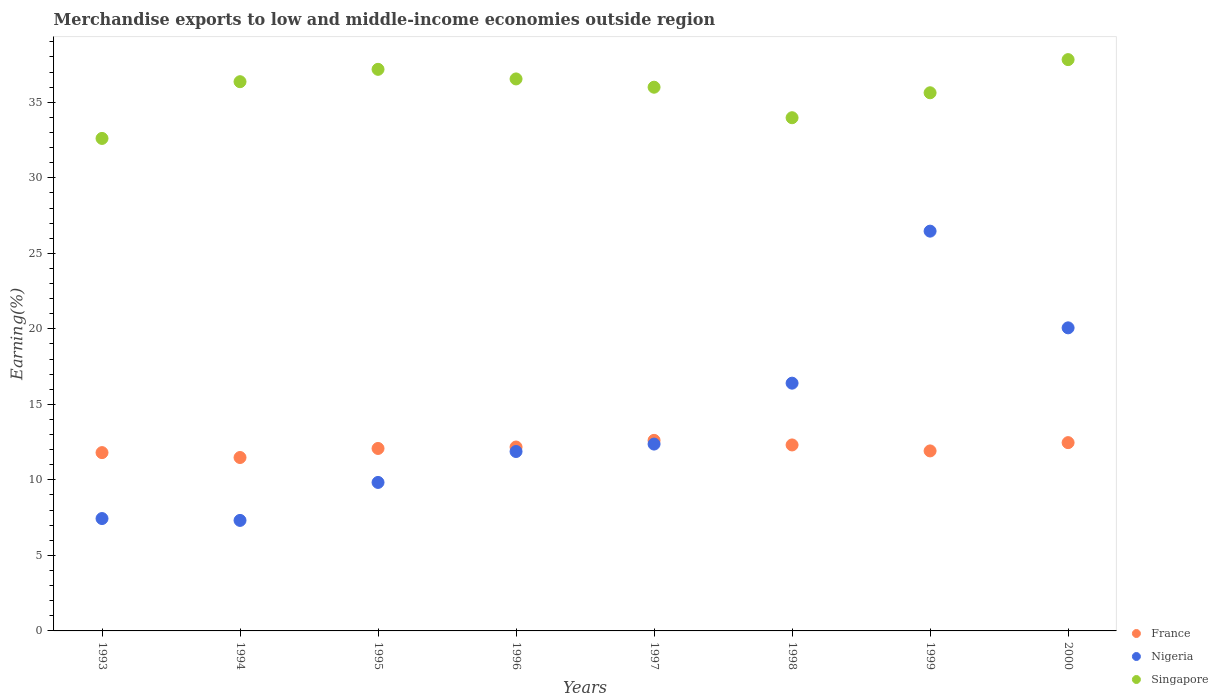How many different coloured dotlines are there?
Make the answer very short. 3. What is the percentage of amount earned from merchandise exports in France in 1999?
Your response must be concise. 11.92. Across all years, what is the maximum percentage of amount earned from merchandise exports in Nigeria?
Ensure brevity in your answer.  26.47. Across all years, what is the minimum percentage of amount earned from merchandise exports in Nigeria?
Your answer should be compact. 7.32. In which year was the percentage of amount earned from merchandise exports in France maximum?
Your response must be concise. 1997. What is the total percentage of amount earned from merchandise exports in Singapore in the graph?
Make the answer very short. 286.12. What is the difference between the percentage of amount earned from merchandise exports in Nigeria in 1994 and that in 1996?
Offer a terse response. -4.56. What is the difference between the percentage of amount earned from merchandise exports in Nigeria in 1995 and the percentage of amount earned from merchandise exports in France in 1996?
Offer a terse response. -2.34. What is the average percentage of amount earned from merchandise exports in Nigeria per year?
Offer a terse response. 13.97. In the year 1995, what is the difference between the percentage of amount earned from merchandise exports in Singapore and percentage of amount earned from merchandise exports in France?
Your response must be concise. 25.1. What is the ratio of the percentage of amount earned from merchandise exports in Singapore in 1993 to that in 1997?
Give a very brief answer. 0.91. What is the difference between the highest and the second highest percentage of amount earned from merchandise exports in France?
Your answer should be very brief. 0.15. What is the difference between the highest and the lowest percentage of amount earned from merchandise exports in France?
Your response must be concise. 1.13. In how many years, is the percentage of amount earned from merchandise exports in Singapore greater than the average percentage of amount earned from merchandise exports in Singapore taken over all years?
Your answer should be very brief. 5. Is the sum of the percentage of amount earned from merchandise exports in Nigeria in 1995 and 1996 greater than the maximum percentage of amount earned from merchandise exports in Singapore across all years?
Make the answer very short. No. Is the percentage of amount earned from merchandise exports in Singapore strictly greater than the percentage of amount earned from merchandise exports in Nigeria over the years?
Give a very brief answer. Yes. How many dotlines are there?
Ensure brevity in your answer.  3. Does the graph contain any zero values?
Your answer should be compact. No. Does the graph contain grids?
Provide a succinct answer. No. How many legend labels are there?
Make the answer very short. 3. How are the legend labels stacked?
Offer a very short reply. Vertical. What is the title of the graph?
Your answer should be compact. Merchandise exports to low and middle-income economies outside region. What is the label or title of the X-axis?
Give a very brief answer. Years. What is the label or title of the Y-axis?
Keep it short and to the point. Earning(%). What is the Earning(%) of France in 1993?
Offer a terse response. 11.8. What is the Earning(%) of Nigeria in 1993?
Offer a very short reply. 7.44. What is the Earning(%) of Singapore in 1993?
Provide a succinct answer. 32.61. What is the Earning(%) in France in 1994?
Offer a very short reply. 11.48. What is the Earning(%) in Nigeria in 1994?
Offer a very short reply. 7.32. What is the Earning(%) of Singapore in 1994?
Keep it short and to the point. 36.36. What is the Earning(%) of France in 1995?
Offer a very short reply. 12.08. What is the Earning(%) in Nigeria in 1995?
Your answer should be very brief. 9.83. What is the Earning(%) of Singapore in 1995?
Provide a short and direct response. 37.18. What is the Earning(%) of France in 1996?
Provide a succinct answer. 12.17. What is the Earning(%) of Nigeria in 1996?
Provide a succinct answer. 11.88. What is the Earning(%) of Singapore in 1996?
Provide a succinct answer. 36.55. What is the Earning(%) of France in 1997?
Ensure brevity in your answer.  12.62. What is the Earning(%) of Nigeria in 1997?
Offer a terse response. 12.37. What is the Earning(%) of Singapore in 1997?
Give a very brief answer. 36. What is the Earning(%) of France in 1998?
Offer a very short reply. 12.31. What is the Earning(%) in Nigeria in 1998?
Offer a very short reply. 16.4. What is the Earning(%) in Singapore in 1998?
Give a very brief answer. 33.98. What is the Earning(%) in France in 1999?
Give a very brief answer. 11.92. What is the Earning(%) in Nigeria in 1999?
Offer a very short reply. 26.47. What is the Earning(%) of Singapore in 1999?
Offer a very short reply. 35.63. What is the Earning(%) in France in 2000?
Ensure brevity in your answer.  12.47. What is the Earning(%) of Nigeria in 2000?
Provide a succinct answer. 20.07. What is the Earning(%) of Singapore in 2000?
Keep it short and to the point. 37.82. Across all years, what is the maximum Earning(%) of France?
Give a very brief answer. 12.62. Across all years, what is the maximum Earning(%) in Nigeria?
Offer a very short reply. 26.47. Across all years, what is the maximum Earning(%) in Singapore?
Provide a short and direct response. 37.82. Across all years, what is the minimum Earning(%) of France?
Ensure brevity in your answer.  11.48. Across all years, what is the minimum Earning(%) of Nigeria?
Your answer should be compact. 7.32. Across all years, what is the minimum Earning(%) of Singapore?
Provide a short and direct response. 32.61. What is the total Earning(%) in France in the graph?
Provide a succinct answer. 96.85. What is the total Earning(%) in Nigeria in the graph?
Your response must be concise. 111.77. What is the total Earning(%) of Singapore in the graph?
Provide a short and direct response. 286.12. What is the difference between the Earning(%) of France in 1993 and that in 1994?
Your answer should be compact. 0.32. What is the difference between the Earning(%) of Nigeria in 1993 and that in 1994?
Your response must be concise. 0.12. What is the difference between the Earning(%) in Singapore in 1993 and that in 1994?
Offer a terse response. -3.76. What is the difference between the Earning(%) of France in 1993 and that in 1995?
Ensure brevity in your answer.  -0.28. What is the difference between the Earning(%) of Nigeria in 1993 and that in 1995?
Offer a terse response. -2.39. What is the difference between the Earning(%) in Singapore in 1993 and that in 1995?
Your response must be concise. -4.57. What is the difference between the Earning(%) of France in 1993 and that in 1996?
Your answer should be compact. -0.37. What is the difference between the Earning(%) of Nigeria in 1993 and that in 1996?
Make the answer very short. -4.44. What is the difference between the Earning(%) of Singapore in 1993 and that in 1996?
Ensure brevity in your answer.  -3.94. What is the difference between the Earning(%) in France in 1993 and that in 1997?
Your answer should be compact. -0.81. What is the difference between the Earning(%) of Nigeria in 1993 and that in 1997?
Give a very brief answer. -4.93. What is the difference between the Earning(%) in Singapore in 1993 and that in 1997?
Provide a succinct answer. -3.39. What is the difference between the Earning(%) in France in 1993 and that in 1998?
Provide a succinct answer. -0.51. What is the difference between the Earning(%) of Nigeria in 1993 and that in 1998?
Your answer should be very brief. -8.96. What is the difference between the Earning(%) in Singapore in 1993 and that in 1998?
Give a very brief answer. -1.37. What is the difference between the Earning(%) in France in 1993 and that in 1999?
Provide a short and direct response. -0.11. What is the difference between the Earning(%) in Nigeria in 1993 and that in 1999?
Provide a short and direct response. -19.03. What is the difference between the Earning(%) in Singapore in 1993 and that in 1999?
Offer a terse response. -3.02. What is the difference between the Earning(%) in France in 1993 and that in 2000?
Your answer should be compact. -0.66. What is the difference between the Earning(%) of Nigeria in 1993 and that in 2000?
Give a very brief answer. -12.63. What is the difference between the Earning(%) in Singapore in 1993 and that in 2000?
Keep it short and to the point. -5.22. What is the difference between the Earning(%) of France in 1994 and that in 1995?
Provide a succinct answer. -0.6. What is the difference between the Earning(%) in Nigeria in 1994 and that in 1995?
Your answer should be compact. -2.51. What is the difference between the Earning(%) in Singapore in 1994 and that in 1995?
Ensure brevity in your answer.  -0.82. What is the difference between the Earning(%) of France in 1994 and that in 1996?
Your answer should be compact. -0.69. What is the difference between the Earning(%) in Nigeria in 1994 and that in 1996?
Give a very brief answer. -4.56. What is the difference between the Earning(%) of Singapore in 1994 and that in 1996?
Give a very brief answer. -0.18. What is the difference between the Earning(%) in France in 1994 and that in 1997?
Your response must be concise. -1.13. What is the difference between the Earning(%) of Nigeria in 1994 and that in 1997?
Give a very brief answer. -5.05. What is the difference between the Earning(%) in Singapore in 1994 and that in 1997?
Your response must be concise. 0.37. What is the difference between the Earning(%) in France in 1994 and that in 1998?
Provide a short and direct response. -0.83. What is the difference between the Earning(%) in Nigeria in 1994 and that in 1998?
Offer a terse response. -9.09. What is the difference between the Earning(%) of Singapore in 1994 and that in 1998?
Keep it short and to the point. 2.38. What is the difference between the Earning(%) of France in 1994 and that in 1999?
Your answer should be compact. -0.44. What is the difference between the Earning(%) of Nigeria in 1994 and that in 1999?
Your answer should be very brief. -19.15. What is the difference between the Earning(%) of Singapore in 1994 and that in 1999?
Make the answer very short. 0.73. What is the difference between the Earning(%) in France in 1994 and that in 2000?
Your answer should be very brief. -0.98. What is the difference between the Earning(%) of Nigeria in 1994 and that in 2000?
Your answer should be very brief. -12.75. What is the difference between the Earning(%) in Singapore in 1994 and that in 2000?
Make the answer very short. -1.46. What is the difference between the Earning(%) of France in 1995 and that in 1996?
Keep it short and to the point. -0.09. What is the difference between the Earning(%) of Nigeria in 1995 and that in 1996?
Offer a terse response. -2.05. What is the difference between the Earning(%) in Singapore in 1995 and that in 1996?
Make the answer very short. 0.64. What is the difference between the Earning(%) of France in 1995 and that in 1997?
Give a very brief answer. -0.54. What is the difference between the Earning(%) of Nigeria in 1995 and that in 1997?
Keep it short and to the point. -2.54. What is the difference between the Earning(%) of Singapore in 1995 and that in 1997?
Offer a very short reply. 1.18. What is the difference between the Earning(%) in France in 1995 and that in 1998?
Keep it short and to the point. -0.23. What is the difference between the Earning(%) of Nigeria in 1995 and that in 1998?
Your answer should be very brief. -6.57. What is the difference between the Earning(%) in Singapore in 1995 and that in 1998?
Offer a very short reply. 3.2. What is the difference between the Earning(%) in France in 1995 and that in 1999?
Make the answer very short. 0.16. What is the difference between the Earning(%) of Nigeria in 1995 and that in 1999?
Keep it short and to the point. -16.64. What is the difference between the Earning(%) of Singapore in 1995 and that in 1999?
Provide a succinct answer. 1.55. What is the difference between the Earning(%) in France in 1995 and that in 2000?
Your answer should be compact. -0.39. What is the difference between the Earning(%) in Nigeria in 1995 and that in 2000?
Offer a very short reply. -10.23. What is the difference between the Earning(%) of Singapore in 1995 and that in 2000?
Your answer should be compact. -0.64. What is the difference between the Earning(%) of France in 1996 and that in 1997?
Your response must be concise. -0.44. What is the difference between the Earning(%) of Nigeria in 1996 and that in 1997?
Give a very brief answer. -0.49. What is the difference between the Earning(%) of Singapore in 1996 and that in 1997?
Offer a terse response. 0.55. What is the difference between the Earning(%) in France in 1996 and that in 1998?
Provide a short and direct response. -0.14. What is the difference between the Earning(%) of Nigeria in 1996 and that in 1998?
Your answer should be very brief. -4.52. What is the difference between the Earning(%) in Singapore in 1996 and that in 1998?
Your answer should be compact. 2.57. What is the difference between the Earning(%) of France in 1996 and that in 1999?
Offer a terse response. 0.26. What is the difference between the Earning(%) of Nigeria in 1996 and that in 1999?
Provide a short and direct response. -14.59. What is the difference between the Earning(%) in France in 1996 and that in 2000?
Offer a terse response. -0.29. What is the difference between the Earning(%) of Nigeria in 1996 and that in 2000?
Give a very brief answer. -8.19. What is the difference between the Earning(%) of Singapore in 1996 and that in 2000?
Offer a terse response. -1.28. What is the difference between the Earning(%) of France in 1997 and that in 1998?
Your answer should be very brief. 0.3. What is the difference between the Earning(%) of Nigeria in 1997 and that in 1998?
Offer a terse response. -4.03. What is the difference between the Earning(%) of Singapore in 1997 and that in 1998?
Give a very brief answer. 2.02. What is the difference between the Earning(%) of France in 1997 and that in 1999?
Your answer should be very brief. 0.7. What is the difference between the Earning(%) in Nigeria in 1997 and that in 1999?
Your response must be concise. -14.1. What is the difference between the Earning(%) in Singapore in 1997 and that in 1999?
Your answer should be very brief. 0.37. What is the difference between the Earning(%) in France in 1997 and that in 2000?
Give a very brief answer. 0.15. What is the difference between the Earning(%) in Nigeria in 1997 and that in 2000?
Give a very brief answer. -7.7. What is the difference between the Earning(%) of Singapore in 1997 and that in 2000?
Offer a terse response. -1.83. What is the difference between the Earning(%) in France in 1998 and that in 1999?
Make the answer very short. 0.4. What is the difference between the Earning(%) of Nigeria in 1998 and that in 1999?
Make the answer very short. -10.06. What is the difference between the Earning(%) in Singapore in 1998 and that in 1999?
Your answer should be very brief. -1.65. What is the difference between the Earning(%) in France in 1998 and that in 2000?
Provide a succinct answer. -0.15. What is the difference between the Earning(%) of Nigeria in 1998 and that in 2000?
Ensure brevity in your answer.  -3.66. What is the difference between the Earning(%) in Singapore in 1998 and that in 2000?
Make the answer very short. -3.85. What is the difference between the Earning(%) of France in 1999 and that in 2000?
Offer a very short reply. -0.55. What is the difference between the Earning(%) of Nigeria in 1999 and that in 2000?
Your answer should be compact. 6.4. What is the difference between the Earning(%) of Singapore in 1999 and that in 2000?
Your response must be concise. -2.2. What is the difference between the Earning(%) of France in 1993 and the Earning(%) of Nigeria in 1994?
Your response must be concise. 4.49. What is the difference between the Earning(%) of France in 1993 and the Earning(%) of Singapore in 1994?
Provide a short and direct response. -24.56. What is the difference between the Earning(%) of Nigeria in 1993 and the Earning(%) of Singapore in 1994?
Ensure brevity in your answer.  -28.92. What is the difference between the Earning(%) in France in 1993 and the Earning(%) in Nigeria in 1995?
Offer a very short reply. 1.97. What is the difference between the Earning(%) of France in 1993 and the Earning(%) of Singapore in 1995?
Provide a succinct answer. -25.38. What is the difference between the Earning(%) of Nigeria in 1993 and the Earning(%) of Singapore in 1995?
Ensure brevity in your answer.  -29.74. What is the difference between the Earning(%) of France in 1993 and the Earning(%) of Nigeria in 1996?
Your answer should be compact. -0.07. What is the difference between the Earning(%) in France in 1993 and the Earning(%) in Singapore in 1996?
Make the answer very short. -24.74. What is the difference between the Earning(%) in Nigeria in 1993 and the Earning(%) in Singapore in 1996?
Provide a short and direct response. -29.11. What is the difference between the Earning(%) of France in 1993 and the Earning(%) of Nigeria in 1997?
Your answer should be compact. -0.57. What is the difference between the Earning(%) in France in 1993 and the Earning(%) in Singapore in 1997?
Your answer should be compact. -24.19. What is the difference between the Earning(%) of Nigeria in 1993 and the Earning(%) of Singapore in 1997?
Provide a short and direct response. -28.56. What is the difference between the Earning(%) of France in 1993 and the Earning(%) of Nigeria in 1998?
Offer a terse response. -4.6. What is the difference between the Earning(%) in France in 1993 and the Earning(%) in Singapore in 1998?
Make the answer very short. -22.17. What is the difference between the Earning(%) in Nigeria in 1993 and the Earning(%) in Singapore in 1998?
Provide a succinct answer. -26.54. What is the difference between the Earning(%) in France in 1993 and the Earning(%) in Nigeria in 1999?
Ensure brevity in your answer.  -14.66. What is the difference between the Earning(%) of France in 1993 and the Earning(%) of Singapore in 1999?
Offer a very short reply. -23.82. What is the difference between the Earning(%) of Nigeria in 1993 and the Earning(%) of Singapore in 1999?
Offer a very short reply. -28.19. What is the difference between the Earning(%) of France in 1993 and the Earning(%) of Nigeria in 2000?
Offer a terse response. -8.26. What is the difference between the Earning(%) in France in 1993 and the Earning(%) in Singapore in 2000?
Your response must be concise. -26.02. What is the difference between the Earning(%) in Nigeria in 1993 and the Earning(%) in Singapore in 2000?
Ensure brevity in your answer.  -30.38. What is the difference between the Earning(%) of France in 1994 and the Earning(%) of Nigeria in 1995?
Make the answer very short. 1.65. What is the difference between the Earning(%) of France in 1994 and the Earning(%) of Singapore in 1995?
Your answer should be very brief. -25.7. What is the difference between the Earning(%) of Nigeria in 1994 and the Earning(%) of Singapore in 1995?
Offer a terse response. -29.86. What is the difference between the Earning(%) of France in 1994 and the Earning(%) of Nigeria in 1996?
Keep it short and to the point. -0.4. What is the difference between the Earning(%) of France in 1994 and the Earning(%) of Singapore in 1996?
Your response must be concise. -25.06. What is the difference between the Earning(%) in Nigeria in 1994 and the Earning(%) in Singapore in 1996?
Provide a short and direct response. -29.23. What is the difference between the Earning(%) of France in 1994 and the Earning(%) of Nigeria in 1997?
Give a very brief answer. -0.89. What is the difference between the Earning(%) in France in 1994 and the Earning(%) in Singapore in 1997?
Provide a succinct answer. -24.52. What is the difference between the Earning(%) in Nigeria in 1994 and the Earning(%) in Singapore in 1997?
Make the answer very short. -28.68. What is the difference between the Earning(%) in France in 1994 and the Earning(%) in Nigeria in 1998?
Keep it short and to the point. -4.92. What is the difference between the Earning(%) in France in 1994 and the Earning(%) in Singapore in 1998?
Make the answer very short. -22.5. What is the difference between the Earning(%) of Nigeria in 1994 and the Earning(%) of Singapore in 1998?
Your answer should be very brief. -26.66. What is the difference between the Earning(%) in France in 1994 and the Earning(%) in Nigeria in 1999?
Your response must be concise. -14.99. What is the difference between the Earning(%) in France in 1994 and the Earning(%) in Singapore in 1999?
Provide a short and direct response. -24.15. What is the difference between the Earning(%) of Nigeria in 1994 and the Earning(%) of Singapore in 1999?
Offer a very short reply. -28.31. What is the difference between the Earning(%) in France in 1994 and the Earning(%) in Nigeria in 2000?
Provide a succinct answer. -8.58. What is the difference between the Earning(%) of France in 1994 and the Earning(%) of Singapore in 2000?
Provide a short and direct response. -26.34. What is the difference between the Earning(%) in Nigeria in 1994 and the Earning(%) in Singapore in 2000?
Provide a succinct answer. -30.51. What is the difference between the Earning(%) in France in 1995 and the Earning(%) in Nigeria in 1996?
Give a very brief answer. 0.2. What is the difference between the Earning(%) of France in 1995 and the Earning(%) of Singapore in 1996?
Ensure brevity in your answer.  -24.47. What is the difference between the Earning(%) in Nigeria in 1995 and the Earning(%) in Singapore in 1996?
Provide a succinct answer. -26.71. What is the difference between the Earning(%) in France in 1995 and the Earning(%) in Nigeria in 1997?
Your answer should be very brief. -0.29. What is the difference between the Earning(%) of France in 1995 and the Earning(%) of Singapore in 1997?
Offer a very short reply. -23.92. What is the difference between the Earning(%) in Nigeria in 1995 and the Earning(%) in Singapore in 1997?
Make the answer very short. -26.17. What is the difference between the Earning(%) in France in 1995 and the Earning(%) in Nigeria in 1998?
Your answer should be very brief. -4.32. What is the difference between the Earning(%) in France in 1995 and the Earning(%) in Singapore in 1998?
Keep it short and to the point. -21.9. What is the difference between the Earning(%) in Nigeria in 1995 and the Earning(%) in Singapore in 1998?
Offer a terse response. -24.15. What is the difference between the Earning(%) in France in 1995 and the Earning(%) in Nigeria in 1999?
Ensure brevity in your answer.  -14.39. What is the difference between the Earning(%) of France in 1995 and the Earning(%) of Singapore in 1999?
Give a very brief answer. -23.55. What is the difference between the Earning(%) in Nigeria in 1995 and the Earning(%) in Singapore in 1999?
Provide a short and direct response. -25.8. What is the difference between the Earning(%) of France in 1995 and the Earning(%) of Nigeria in 2000?
Your answer should be compact. -7.99. What is the difference between the Earning(%) in France in 1995 and the Earning(%) in Singapore in 2000?
Make the answer very short. -25.74. What is the difference between the Earning(%) of Nigeria in 1995 and the Earning(%) of Singapore in 2000?
Keep it short and to the point. -27.99. What is the difference between the Earning(%) of France in 1996 and the Earning(%) of Nigeria in 1997?
Provide a short and direct response. -0.2. What is the difference between the Earning(%) in France in 1996 and the Earning(%) in Singapore in 1997?
Provide a short and direct response. -23.82. What is the difference between the Earning(%) of Nigeria in 1996 and the Earning(%) of Singapore in 1997?
Ensure brevity in your answer.  -24.12. What is the difference between the Earning(%) of France in 1996 and the Earning(%) of Nigeria in 1998?
Your response must be concise. -4.23. What is the difference between the Earning(%) in France in 1996 and the Earning(%) in Singapore in 1998?
Make the answer very short. -21.8. What is the difference between the Earning(%) of Nigeria in 1996 and the Earning(%) of Singapore in 1998?
Provide a short and direct response. -22.1. What is the difference between the Earning(%) in France in 1996 and the Earning(%) in Nigeria in 1999?
Give a very brief answer. -14.29. What is the difference between the Earning(%) of France in 1996 and the Earning(%) of Singapore in 1999?
Your response must be concise. -23.45. What is the difference between the Earning(%) in Nigeria in 1996 and the Earning(%) in Singapore in 1999?
Your answer should be very brief. -23.75. What is the difference between the Earning(%) in France in 1996 and the Earning(%) in Nigeria in 2000?
Make the answer very short. -7.89. What is the difference between the Earning(%) in France in 1996 and the Earning(%) in Singapore in 2000?
Give a very brief answer. -25.65. What is the difference between the Earning(%) in Nigeria in 1996 and the Earning(%) in Singapore in 2000?
Make the answer very short. -25.95. What is the difference between the Earning(%) of France in 1997 and the Earning(%) of Nigeria in 1998?
Ensure brevity in your answer.  -3.79. What is the difference between the Earning(%) of France in 1997 and the Earning(%) of Singapore in 1998?
Give a very brief answer. -21.36. What is the difference between the Earning(%) of Nigeria in 1997 and the Earning(%) of Singapore in 1998?
Offer a terse response. -21.61. What is the difference between the Earning(%) in France in 1997 and the Earning(%) in Nigeria in 1999?
Provide a succinct answer. -13.85. What is the difference between the Earning(%) of France in 1997 and the Earning(%) of Singapore in 1999?
Ensure brevity in your answer.  -23.01. What is the difference between the Earning(%) in Nigeria in 1997 and the Earning(%) in Singapore in 1999?
Provide a succinct answer. -23.26. What is the difference between the Earning(%) of France in 1997 and the Earning(%) of Nigeria in 2000?
Ensure brevity in your answer.  -7.45. What is the difference between the Earning(%) of France in 1997 and the Earning(%) of Singapore in 2000?
Provide a succinct answer. -25.21. What is the difference between the Earning(%) of Nigeria in 1997 and the Earning(%) of Singapore in 2000?
Keep it short and to the point. -25.45. What is the difference between the Earning(%) in France in 1998 and the Earning(%) in Nigeria in 1999?
Your response must be concise. -14.15. What is the difference between the Earning(%) in France in 1998 and the Earning(%) in Singapore in 1999?
Your response must be concise. -23.32. What is the difference between the Earning(%) in Nigeria in 1998 and the Earning(%) in Singapore in 1999?
Your response must be concise. -19.23. What is the difference between the Earning(%) of France in 1998 and the Earning(%) of Nigeria in 2000?
Provide a succinct answer. -7.75. What is the difference between the Earning(%) in France in 1998 and the Earning(%) in Singapore in 2000?
Ensure brevity in your answer.  -25.51. What is the difference between the Earning(%) in Nigeria in 1998 and the Earning(%) in Singapore in 2000?
Your answer should be very brief. -21.42. What is the difference between the Earning(%) in France in 1999 and the Earning(%) in Nigeria in 2000?
Make the answer very short. -8.15. What is the difference between the Earning(%) of France in 1999 and the Earning(%) of Singapore in 2000?
Keep it short and to the point. -25.91. What is the difference between the Earning(%) of Nigeria in 1999 and the Earning(%) of Singapore in 2000?
Make the answer very short. -11.36. What is the average Earning(%) in France per year?
Keep it short and to the point. 12.11. What is the average Earning(%) in Nigeria per year?
Your response must be concise. 13.97. What is the average Earning(%) in Singapore per year?
Your answer should be compact. 35.77. In the year 1993, what is the difference between the Earning(%) of France and Earning(%) of Nigeria?
Offer a very short reply. 4.36. In the year 1993, what is the difference between the Earning(%) of France and Earning(%) of Singapore?
Ensure brevity in your answer.  -20.8. In the year 1993, what is the difference between the Earning(%) in Nigeria and Earning(%) in Singapore?
Ensure brevity in your answer.  -25.17. In the year 1994, what is the difference between the Earning(%) of France and Earning(%) of Nigeria?
Your answer should be very brief. 4.16. In the year 1994, what is the difference between the Earning(%) of France and Earning(%) of Singapore?
Your response must be concise. -24.88. In the year 1994, what is the difference between the Earning(%) in Nigeria and Earning(%) in Singapore?
Make the answer very short. -29.05. In the year 1995, what is the difference between the Earning(%) of France and Earning(%) of Nigeria?
Offer a terse response. 2.25. In the year 1995, what is the difference between the Earning(%) of France and Earning(%) of Singapore?
Make the answer very short. -25.1. In the year 1995, what is the difference between the Earning(%) in Nigeria and Earning(%) in Singapore?
Offer a very short reply. -27.35. In the year 1996, what is the difference between the Earning(%) of France and Earning(%) of Nigeria?
Your response must be concise. 0.3. In the year 1996, what is the difference between the Earning(%) in France and Earning(%) in Singapore?
Your response must be concise. -24.37. In the year 1996, what is the difference between the Earning(%) in Nigeria and Earning(%) in Singapore?
Ensure brevity in your answer.  -24.67. In the year 1997, what is the difference between the Earning(%) of France and Earning(%) of Nigeria?
Your response must be concise. 0.25. In the year 1997, what is the difference between the Earning(%) of France and Earning(%) of Singapore?
Make the answer very short. -23.38. In the year 1997, what is the difference between the Earning(%) of Nigeria and Earning(%) of Singapore?
Offer a very short reply. -23.63. In the year 1998, what is the difference between the Earning(%) of France and Earning(%) of Nigeria?
Your answer should be very brief. -4.09. In the year 1998, what is the difference between the Earning(%) in France and Earning(%) in Singapore?
Your answer should be compact. -21.66. In the year 1998, what is the difference between the Earning(%) in Nigeria and Earning(%) in Singapore?
Give a very brief answer. -17.57. In the year 1999, what is the difference between the Earning(%) in France and Earning(%) in Nigeria?
Provide a short and direct response. -14.55. In the year 1999, what is the difference between the Earning(%) of France and Earning(%) of Singapore?
Make the answer very short. -23.71. In the year 1999, what is the difference between the Earning(%) in Nigeria and Earning(%) in Singapore?
Offer a terse response. -9.16. In the year 2000, what is the difference between the Earning(%) in France and Earning(%) in Nigeria?
Provide a succinct answer. -7.6. In the year 2000, what is the difference between the Earning(%) in France and Earning(%) in Singapore?
Offer a terse response. -25.36. In the year 2000, what is the difference between the Earning(%) of Nigeria and Earning(%) of Singapore?
Offer a very short reply. -17.76. What is the ratio of the Earning(%) in France in 1993 to that in 1994?
Your answer should be compact. 1.03. What is the ratio of the Earning(%) of Nigeria in 1993 to that in 1994?
Your answer should be compact. 1.02. What is the ratio of the Earning(%) in Singapore in 1993 to that in 1994?
Provide a short and direct response. 0.9. What is the ratio of the Earning(%) of France in 1993 to that in 1995?
Offer a very short reply. 0.98. What is the ratio of the Earning(%) of Nigeria in 1993 to that in 1995?
Your answer should be very brief. 0.76. What is the ratio of the Earning(%) in Singapore in 1993 to that in 1995?
Keep it short and to the point. 0.88. What is the ratio of the Earning(%) of France in 1993 to that in 1996?
Your answer should be very brief. 0.97. What is the ratio of the Earning(%) in Nigeria in 1993 to that in 1996?
Your answer should be compact. 0.63. What is the ratio of the Earning(%) of Singapore in 1993 to that in 1996?
Your answer should be compact. 0.89. What is the ratio of the Earning(%) of France in 1993 to that in 1997?
Keep it short and to the point. 0.94. What is the ratio of the Earning(%) in Nigeria in 1993 to that in 1997?
Ensure brevity in your answer.  0.6. What is the ratio of the Earning(%) of Singapore in 1993 to that in 1997?
Make the answer very short. 0.91. What is the ratio of the Earning(%) of France in 1993 to that in 1998?
Provide a succinct answer. 0.96. What is the ratio of the Earning(%) in Nigeria in 1993 to that in 1998?
Make the answer very short. 0.45. What is the ratio of the Earning(%) of Singapore in 1993 to that in 1998?
Give a very brief answer. 0.96. What is the ratio of the Earning(%) in Nigeria in 1993 to that in 1999?
Your answer should be very brief. 0.28. What is the ratio of the Earning(%) of Singapore in 1993 to that in 1999?
Provide a short and direct response. 0.92. What is the ratio of the Earning(%) of France in 1993 to that in 2000?
Offer a very short reply. 0.95. What is the ratio of the Earning(%) of Nigeria in 1993 to that in 2000?
Offer a very short reply. 0.37. What is the ratio of the Earning(%) in Singapore in 1993 to that in 2000?
Your answer should be very brief. 0.86. What is the ratio of the Earning(%) of France in 1994 to that in 1995?
Your answer should be compact. 0.95. What is the ratio of the Earning(%) of Nigeria in 1994 to that in 1995?
Your answer should be very brief. 0.74. What is the ratio of the Earning(%) of Singapore in 1994 to that in 1995?
Make the answer very short. 0.98. What is the ratio of the Earning(%) of France in 1994 to that in 1996?
Provide a short and direct response. 0.94. What is the ratio of the Earning(%) in Nigeria in 1994 to that in 1996?
Keep it short and to the point. 0.62. What is the ratio of the Earning(%) of France in 1994 to that in 1997?
Your response must be concise. 0.91. What is the ratio of the Earning(%) of Nigeria in 1994 to that in 1997?
Ensure brevity in your answer.  0.59. What is the ratio of the Earning(%) of Singapore in 1994 to that in 1997?
Make the answer very short. 1.01. What is the ratio of the Earning(%) in France in 1994 to that in 1998?
Keep it short and to the point. 0.93. What is the ratio of the Earning(%) of Nigeria in 1994 to that in 1998?
Your answer should be compact. 0.45. What is the ratio of the Earning(%) in Singapore in 1994 to that in 1998?
Provide a succinct answer. 1.07. What is the ratio of the Earning(%) in France in 1994 to that in 1999?
Give a very brief answer. 0.96. What is the ratio of the Earning(%) of Nigeria in 1994 to that in 1999?
Your response must be concise. 0.28. What is the ratio of the Earning(%) in Singapore in 1994 to that in 1999?
Ensure brevity in your answer.  1.02. What is the ratio of the Earning(%) in France in 1994 to that in 2000?
Your answer should be compact. 0.92. What is the ratio of the Earning(%) in Nigeria in 1994 to that in 2000?
Give a very brief answer. 0.36. What is the ratio of the Earning(%) of Singapore in 1994 to that in 2000?
Your answer should be compact. 0.96. What is the ratio of the Earning(%) of Nigeria in 1995 to that in 1996?
Offer a terse response. 0.83. What is the ratio of the Earning(%) in Singapore in 1995 to that in 1996?
Ensure brevity in your answer.  1.02. What is the ratio of the Earning(%) in France in 1995 to that in 1997?
Ensure brevity in your answer.  0.96. What is the ratio of the Earning(%) of Nigeria in 1995 to that in 1997?
Your answer should be very brief. 0.79. What is the ratio of the Earning(%) of Singapore in 1995 to that in 1997?
Your answer should be very brief. 1.03. What is the ratio of the Earning(%) of France in 1995 to that in 1998?
Keep it short and to the point. 0.98. What is the ratio of the Earning(%) in Nigeria in 1995 to that in 1998?
Provide a short and direct response. 0.6. What is the ratio of the Earning(%) in Singapore in 1995 to that in 1998?
Offer a terse response. 1.09. What is the ratio of the Earning(%) of France in 1995 to that in 1999?
Your answer should be very brief. 1.01. What is the ratio of the Earning(%) in Nigeria in 1995 to that in 1999?
Keep it short and to the point. 0.37. What is the ratio of the Earning(%) of Singapore in 1995 to that in 1999?
Provide a short and direct response. 1.04. What is the ratio of the Earning(%) of France in 1995 to that in 2000?
Your answer should be very brief. 0.97. What is the ratio of the Earning(%) in Nigeria in 1995 to that in 2000?
Offer a terse response. 0.49. What is the ratio of the Earning(%) in France in 1996 to that in 1997?
Your response must be concise. 0.97. What is the ratio of the Earning(%) of Nigeria in 1996 to that in 1997?
Make the answer very short. 0.96. What is the ratio of the Earning(%) of Singapore in 1996 to that in 1997?
Ensure brevity in your answer.  1.02. What is the ratio of the Earning(%) in France in 1996 to that in 1998?
Your answer should be very brief. 0.99. What is the ratio of the Earning(%) of Nigeria in 1996 to that in 1998?
Your answer should be compact. 0.72. What is the ratio of the Earning(%) of Singapore in 1996 to that in 1998?
Keep it short and to the point. 1.08. What is the ratio of the Earning(%) of France in 1996 to that in 1999?
Your answer should be very brief. 1.02. What is the ratio of the Earning(%) of Nigeria in 1996 to that in 1999?
Provide a succinct answer. 0.45. What is the ratio of the Earning(%) in Singapore in 1996 to that in 1999?
Keep it short and to the point. 1.03. What is the ratio of the Earning(%) in France in 1996 to that in 2000?
Offer a very short reply. 0.98. What is the ratio of the Earning(%) in Nigeria in 1996 to that in 2000?
Provide a succinct answer. 0.59. What is the ratio of the Earning(%) of Singapore in 1996 to that in 2000?
Make the answer very short. 0.97. What is the ratio of the Earning(%) in France in 1997 to that in 1998?
Ensure brevity in your answer.  1.02. What is the ratio of the Earning(%) of Nigeria in 1997 to that in 1998?
Keep it short and to the point. 0.75. What is the ratio of the Earning(%) of Singapore in 1997 to that in 1998?
Provide a short and direct response. 1.06. What is the ratio of the Earning(%) in France in 1997 to that in 1999?
Ensure brevity in your answer.  1.06. What is the ratio of the Earning(%) in Nigeria in 1997 to that in 1999?
Provide a succinct answer. 0.47. What is the ratio of the Earning(%) in Singapore in 1997 to that in 1999?
Your response must be concise. 1.01. What is the ratio of the Earning(%) of Nigeria in 1997 to that in 2000?
Offer a terse response. 0.62. What is the ratio of the Earning(%) in Singapore in 1997 to that in 2000?
Your response must be concise. 0.95. What is the ratio of the Earning(%) in France in 1998 to that in 1999?
Your response must be concise. 1.03. What is the ratio of the Earning(%) in Nigeria in 1998 to that in 1999?
Offer a terse response. 0.62. What is the ratio of the Earning(%) in Singapore in 1998 to that in 1999?
Your answer should be compact. 0.95. What is the ratio of the Earning(%) in Nigeria in 1998 to that in 2000?
Offer a terse response. 0.82. What is the ratio of the Earning(%) of Singapore in 1998 to that in 2000?
Your response must be concise. 0.9. What is the ratio of the Earning(%) in France in 1999 to that in 2000?
Give a very brief answer. 0.96. What is the ratio of the Earning(%) of Nigeria in 1999 to that in 2000?
Ensure brevity in your answer.  1.32. What is the ratio of the Earning(%) of Singapore in 1999 to that in 2000?
Your answer should be very brief. 0.94. What is the difference between the highest and the second highest Earning(%) of France?
Ensure brevity in your answer.  0.15. What is the difference between the highest and the second highest Earning(%) in Nigeria?
Offer a terse response. 6.4. What is the difference between the highest and the second highest Earning(%) of Singapore?
Make the answer very short. 0.64. What is the difference between the highest and the lowest Earning(%) in France?
Ensure brevity in your answer.  1.13. What is the difference between the highest and the lowest Earning(%) of Nigeria?
Keep it short and to the point. 19.15. What is the difference between the highest and the lowest Earning(%) in Singapore?
Offer a terse response. 5.22. 